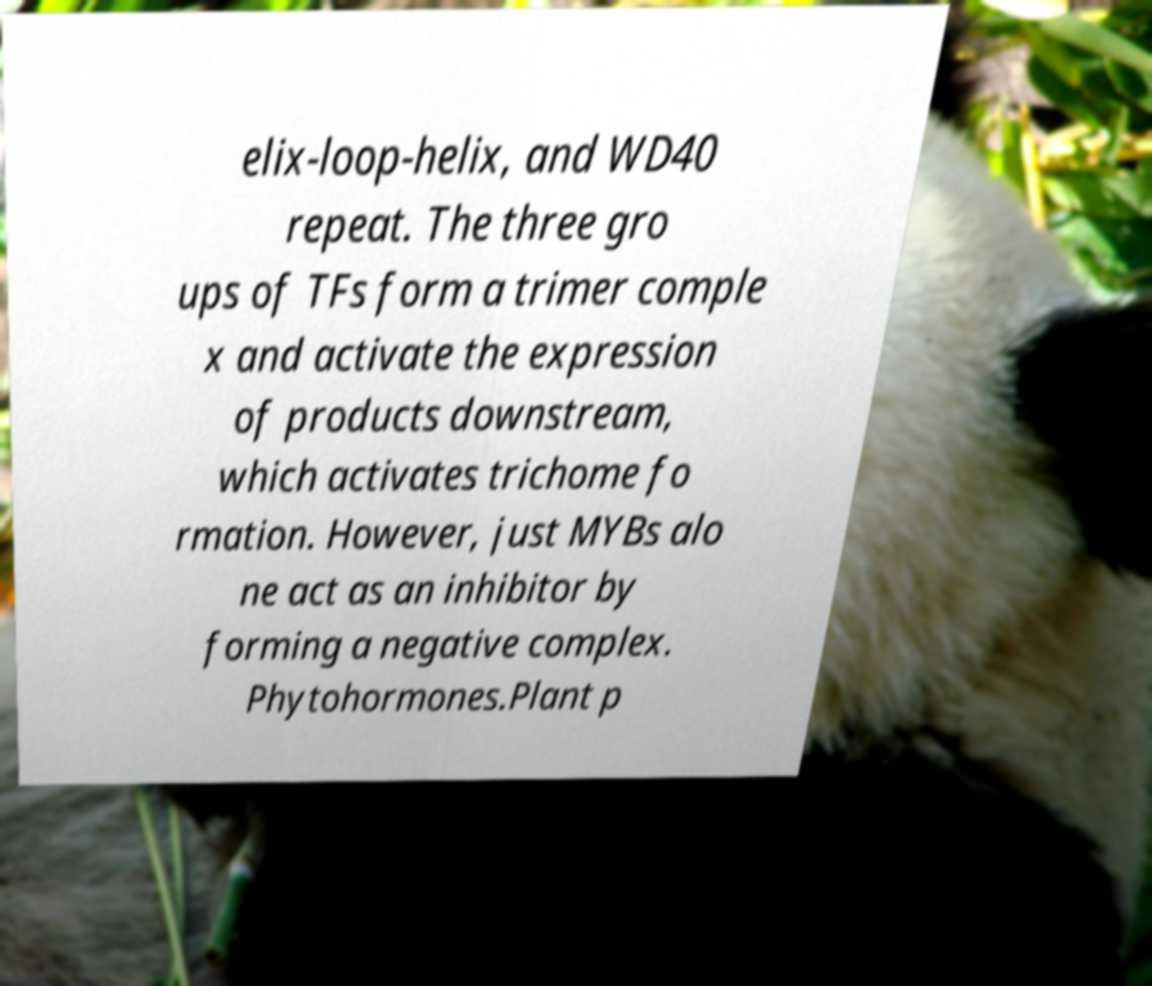Could you assist in decoding the text presented in this image and type it out clearly? elix-loop-helix, and WD40 repeat. The three gro ups of TFs form a trimer comple x and activate the expression of products downstream, which activates trichome fo rmation. However, just MYBs alo ne act as an inhibitor by forming a negative complex. Phytohormones.Plant p 